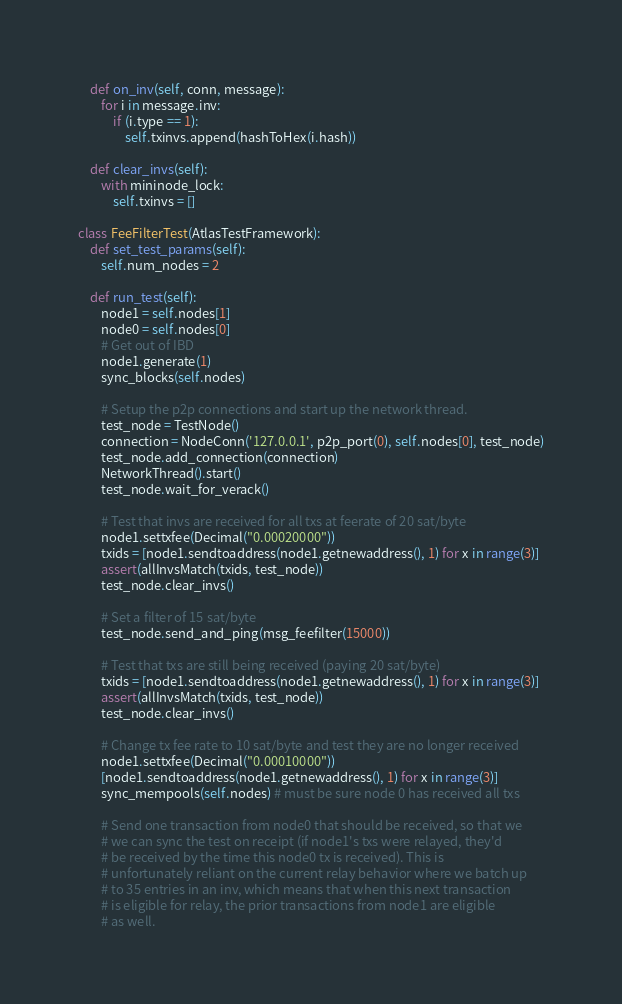Convert code to text. <code><loc_0><loc_0><loc_500><loc_500><_Python_>
    def on_inv(self, conn, message):
        for i in message.inv:
            if (i.type == 1):
                self.txinvs.append(hashToHex(i.hash))

    def clear_invs(self):
        with mininode_lock:
            self.txinvs = []

class FeeFilterTest(AtlasTestFramework):
    def set_test_params(self):
        self.num_nodes = 2

    def run_test(self):
        node1 = self.nodes[1]
        node0 = self.nodes[0]
        # Get out of IBD
        node1.generate(1)
        sync_blocks(self.nodes)

        # Setup the p2p connections and start up the network thread.
        test_node = TestNode()
        connection = NodeConn('127.0.0.1', p2p_port(0), self.nodes[0], test_node)
        test_node.add_connection(connection)
        NetworkThread().start()
        test_node.wait_for_verack()

        # Test that invs are received for all txs at feerate of 20 sat/byte
        node1.settxfee(Decimal("0.00020000"))
        txids = [node1.sendtoaddress(node1.getnewaddress(), 1) for x in range(3)]
        assert(allInvsMatch(txids, test_node))
        test_node.clear_invs()

        # Set a filter of 15 sat/byte
        test_node.send_and_ping(msg_feefilter(15000))

        # Test that txs are still being received (paying 20 sat/byte)
        txids = [node1.sendtoaddress(node1.getnewaddress(), 1) for x in range(3)]
        assert(allInvsMatch(txids, test_node))
        test_node.clear_invs()

        # Change tx fee rate to 10 sat/byte and test they are no longer received
        node1.settxfee(Decimal("0.00010000"))
        [node1.sendtoaddress(node1.getnewaddress(), 1) for x in range(3)]
        sync_mempools(self.nodes) # must be sure node 0 has received all txs 

        # Send one transaction from node0 that should be received, so that we
        # we can sync the test on receipt (if node1's txs were relayed, they'd
        # be received by the time this node0 tx is received). This is
        # unfortunately reliant on the current relay behavior where we batch up
        # to 35 entries in an inv, which means that when this next transaction
        # is eligible for relay, the prior transactions from node1 are eligible
        # as well.</code> 